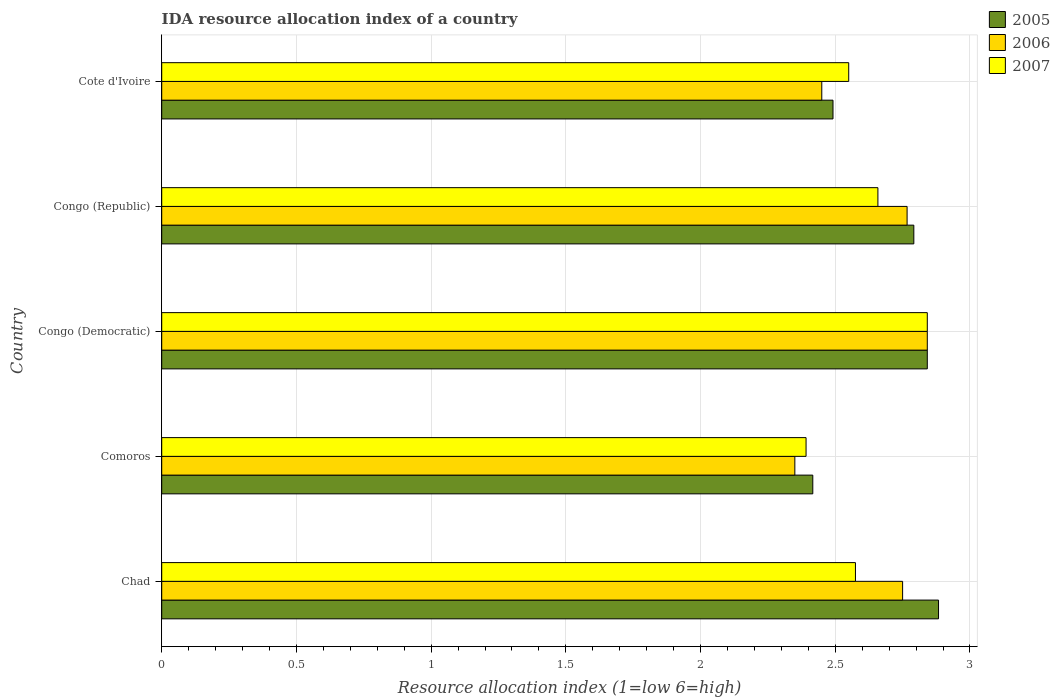How many different coloured bars are there?
Your answer should be very brief. 3. Are the number of bars on each tick of the Y-axis equal?
Your response must be concise. Yes. How many bars are there on the 1st tick from the bottom?
Ensure brevity in your answer.  3. What is the label of the 5th group of bars from the top?
Your response must be concise. Chad. In how many cases, is the number of bars for a given country not equal to the number of legend labels?
Keep it short and to the point. 0. What is the IDA resource allocation index in 2007 in Comoros?
Give a very brief answer. 2.39. Across all countries, what is the maximum IDA resource allocation index in 2007?
Make the answer very short. 2.84. Across all countries, what is the minimum IDA resource allocation index in 2006?
Keep it short and to the point. 2.35. In which country was the IDA resource allocation index in 2006 maximum?
Offer a very short reply. Congo (Democratic). In which country was the IDA resource allocation index in 2006 minimum?
Your answer should be very brief. Comoros. What is the total IDA resource allocation index in 2007 in the graph?
Keep it short and to the point. 13.02. What is the difference between the IDA resource allocation index in 2005 in Congo (Democratic) and that in Cote d'Ivoire?
Make the answer very short. 0.35. What is the difference between the IDA resource allocation index in 2007 in Comoros and the IDA resource allocation index in 2005 in Congo (Democratic)?
Ensure brevity in your answer.  -0.45. What is the average IDA resource allocation index in 2006 per country?
Give a very brief answer. 2.63. What is the ratio of the IDA resource allocation index in 2006 in Chad to that in Cote d'Ivoire?
Make the answer very short. 1.12. Is the IDA resource allocation index in 2007 in Chad less than that in Comoros?
Your response must be concise. No. Is the difference between the IDA resource allocation index in 2007 in Comoros and Cote d'Ivoire greater than the difference between the IDA resource allocation index in 2006 in Comoros and Cote d'Ivoire?
Give a very brief answer. No. What is the difference between the highest and the second highest IDA resource allocation index in 2007?
Ensure brevity in your answer.  0.18. What is the difference between the highest and the lowest IDA resource allocation index in 2006?
Keep it short and to the point. 0.49. Is the sum of the IDA resource allocation index in 2006 in Chad and Congo (Democratic) greater than the maximum IDA resource allocation index in 2007 across all countries?
Make the answer very short. Yes. What does the 3rd bar from the top in Chad represents?
Provide a short and direct response. 2005. What does the 2nd bar from the bottom in Chad represents?
Provide a short and direct response. 2006. How many bars are there?
Provide a succinct answer. 15. How many countries are there in the graph?
Provide a short and direct response. 5. What is the difference between two consecutive major ticks on the X-axis?
Offer a very short reply. 0.5. Are the values on the major ticks of X-axis written in scientific E-notation?
Provide a short and direct response. No. Does the graph contain any zero values?
Keep it short and to the point. No. Does the graph contain grids?
Offer a very short reply. Yes. How many legend labels are there?
Give a very brief answer. 3. What is the title of the graph?
Your answer should be compact. IDA resource allocation index of a country. Does "1964" appear as one of the legend labels in the graph?
Offer a very short reply. No. What is the label or title of the X-axis?
Provide a succinct answer. Resource allocation index (1=low 6=high). What is the label or title of the Y-axis?
Your response must be concise. Country. What is the Resource allocation index (1=low 6=high) of 2005 in Chad?
Offer a terse response. 2.88. What is the Resource allocation index (1=low 6=high) in 2006 in Chad?
Your answer should be very brief. 2.75. What is the Resource allocation index (1=low 6=high) of 2007 in Chad?
Provide a short and direct response. 2.58. What is the Resource allocation index (1=low 6=high) of 2005 in Comoros?
Your response must be concise. 2.42. What is the Resource allocation index (1=low 6=high) of 2006 in Comoros?
Give a very brief answer. 2.35. What is the Resource allocation index (1=low 6=high) of 2007 in Comoros?
Offer a very short reply. 2.39. What is the Resource allocation index (1=low 6=high) of 2005 in Congo (Democratic)?
Give a very brief answer. 2.84. What is the Resource allocation index (1=low 6=high) in 2006 in Congo (Democratic)?
Offer a terse response. 2.84. What is the Resource allocation index (1=low 6=high) in 2007 in Congo (Democratic)?
Give a very brief answer. 2.84. What is the Resource allocation index (1=low 6=high) in 2005 in Congo (Republic)?
Give a very brief answer. 2.79. What is the Resource allocation index (1=low 6=high) of 2006 in Congo (Republic)?
Your answer should be compact. 2.77. What is the Resource allocation index (1=low 6=high) of 2007 in Congo (Republic)?
Provide a succinct answer. 2.66. What is the Resource allocation index (1=low 6=high) in 2005 in Cote d'Ivoire?
Your answer should be very brief. 2.49. What is the Resource allocation index (1=low 6=high) of 2006 in Cote d'Ivoire?
Offer a very short reply. 2.45. What is the Resource allocation index (1=low 6=high) in 2007 in Cote d'Ivoire?
Your answer should be compact. 2.55. Across all countries, what is the maximum Resource allocation index (1=low 6=high) of 2005?
Ensure brevity in your answer.  2.88. Across all countries, what is the maximum Resource allocation index (1=low 6=high) in 2006?
Offer a very short reply. 2.84. Across all countries, what is the maximum Resource allocation index (1=low 6=high) of 2007?
Give a very brief answer. 2.84. Across all countries, what is the minimum Resource allocation index (1=low 6=high) in 2005?
Your answer should be very brief. 2.42. Across all countries, what is the minimum Resource allocation index (1=low 6=high) in 2006?
Provide a succinct answer. 2.35. Across all countries, what is the minimum Resource allocation index (1=low 6=high) of 2007?
Make the answer very short. 2.39. What is the total Resource allocation index (1=low 6=high) in 2005 in the graph?
Keep it short and to the point. 13.43. What is the total Resource allocation index (1=low 6=high) in 2006 in the graph?
Your answer should be very brief. 13.16. What is the total Resource allocation index (1=low 6=high) in 2007 in the graph?
Ensure brevity in your answer.  13.02. What is the difference between the Resource allocation index (1=low 6=high) in 2005 in Chad and that in Comoros?
Your answer should be very brief. 0.47. What is the difference between the Resource allocation index (1=low 6=high) of 2006 in Chad and that in Comoros?
Your answer should be very brief. 0.4. What is the difference between the Resource allocation index (1=low 6=high) of 2007 in Chad and that in Comoros?
Make the answer very short. 0.18. What is the difference between the Resource allocation index (1=low 6=high) of 2005 in Chad and that in Congo (Democratic)?
Provide a short and direct response. 0.04. What is the difference between the Resource allocation index (1=low 6=high) in 2006 in Chad and that in Congo (Democratic)?
Ensure brevity in your answer.  -0.09. What is the difference between the Resource allocation index (1=low 6=high) of 2007 in Chad and that in Congo (Democratic)?
Your answer should be compact. -0.27. What is the difference between the Resource allocation index (1=low 6=high) of 2005 in Chad and that in Congo (Republic)?
Make the answer very short. 0.09. What is the difference between the Resource allocation index (1=low 6=high) of 2006 in Chad and that in Congo (Republic)?
Your answer should be very brief. -0.02. What is the difference between the Resource allocation index (1=low 6=high) of 2007 in Chad and that in Congo (Republic)?
Provide a short and direct response. -0.08. What is the difference between the Resource allocation index (1=low 6=high) of 2005 in Chad and that in Cote d'Ivoire?
Ensure brevity in your answer.  0.39. What is the difference between the Resource allocation index (1=low 6=high) of 2006 in Chad and that in Cote d'Ivoire?
Ensure brevity in your answer.  0.3. What is the difference between the Resource allocation index (1=low 6=high) of 2007 in Chad and that in Cote d'Ivoire?
Your answer should be very brief. 0.03. What is the difference between the Resource allocation index (1=low 6=high) of 2005 in Comoros and that in Congo (Democratic)?
Provide a short and direct response. -0.42. What is the difference between the Resource allocation index (1=low 6=high) of 2006 in Comoros and that in Congo (Democratic)?
Ensure brevity in your answer.  -0.49. What is the difference between the Resource allocation index (1=low 6=high) of 2007 in Comoros and that in Congo (Democratic)?
Offer a very short reply. -0.45. What is the difference between the Resource allocation index (1=low 6=high) in 2005 in Comoros and that in Congo (Republic)?
Your answer should be compact. -0.38. What is the difference between the Resource allocation index (1=low 6=high) in 2006 in Comoros and that in Congo (Republic)?
Your answer should be compact. -0.42. What is the difference between the Resource allocation index (1=low 6=high) in 2007 in Comoros and that in Congo (Republic)?
Keep it short and to the point. -0.27. What is the difference between the Resource allocation index (1=low 6=high) of 2005 in Comoros and that in Cote d'Ivoire?
Provide a short and direct response. -0.07. What is the difference between the Resource allocation index (1=low 6=high) of 2007 in Comoros and that in Cote d'Ivoire?
Ensure brevity in your answer.  -0.16. What is the difference between the Resource allocation index (1=low 6=high) in 2006 in Congo (Democratic) and that in Congo (Republic)?
Make the answer very short. 0.07. What is the difference between the Resource allocation index (1=low 6=high) of 2007 in Congo (Democratic) and that in Congo (Republic)?
Your answer should be very brief. 0.18. What is the difference between the Resource allocation index (1=low 6=high) in 2006 in Congo (Democratic) and that in Cote d'Ivoire?
Your response must be concise. 0.39. What is the difference between the Resource allocation index (1=low 6=high) in 2007 in Congo (Democratic) and that in Cote d'Ivoire?
Ensure brevity in your answer.  0.29. What is the difference between the Resource allocation index (1=low 6=high) in 2005 in Congo (Republic) and that in Cote d'Ivoire?
Provide a succinct answer. 0.3. What is the difference between the Resource allocation index (1=low 6=high) of 2006 in Congo (Republic) and that in Cote d'Ivoire?
Provide a short and direct response. 0.32. What is the difference between the Resource allocation index (1=low 6=high) in 2007 in Congo (Republic) and that in Cote d'Ivoire?
Give a very brief answer. 0.11. What is the difference between the Resource allocation index (1=low 6=high) in 2005 in Chad and the Resource allocation index (1=low 6=high) in 2006 in Comoros?
Your response must be concise. 0.53. What is the difference between the Resource allocation index (1=low 6=high) in 2005 in Chad and the Resource allocation index (1=low 6=high) in 2007 in Comoros?
Make the answer very short. 0.49. What is the difference between the Resource allocation index (1=low 6=high) in 2006 in Chad and the Resource allocation index (1=low 6=high) in 2007 in Comoros?
Give a very brief answer. 0.36. What is the difference between the Resource allocation index (1=low 6=high) of 2005 in Chad and the Resource allocation index (1=low 6=high) of 2006 in Congo (Democratic)?
Ensure brevity in your answer.  0.04. What is the difference between the Resource allocation index (1=low 6=high) in 2005 in Chad and the Resource allocation index (1=low 6=high) in 2007 in Congo (Democratic)?
Ensure brevity in your answer.  0.04. What is the difference between the Resource allocation index (1=low 6=high) of 2006 in Chad and the Resource allocation index (1=low 6=high) of 2007 in Congo (Democratic)?
Offer a very short reply. -0.09. What is the difference between the Resource allocation index (1=low 6=high) of 2005 in Chad and the Resource allocation index (1=low 6=high) of 2006 in Congo (Republic)?
Ensure brevity in your answer.  0.12. What is the difference between the Resource allocation index (1=low 6=high) in 2005 in Chad and the Resource allocation index (1=low 6=high) in 2007 in Congo (Republic)?
Keep it short and to the point. 0.23. What is the difference between the Resource allocation index (1=low 6=high) in 2006 in Chad and the Resource allocation index (1=low 6=high) in 2007 in Congo (Republic)?
Offer a very short reply. 0.09. What is the difference between the Resource allocation index (1=low 6=high) of 2005 in Chad and the Resource allocation index (1=low 6=high) of 2006 in Cote d'Ivoire?
Ensure brevity in your answer.  0.43. What is the difference between the Resource allocation index (1=low 6=high) of 2005 in Chad and the Resource allocation index (1=low 6=high) of 2007 in Cote d'Ivoire?
Offer a terse response. 0.33. What is the difference between the Resource allocation index (1=low 6=high) of 2005 in Comoros and the Resource allocation index (1=low 6=high) of 2006 in Congo (Democratic)?
Give a very brief answer. -0.42. What is the difference between the Resource allocation index (1=low 6=high) of 2005 in Comoros and the Resource allocation index (1=low 6=high) of 2007 in Congo (Democratic)?
Make the answer very short. -0.42. What is the difference between the Resource allocation index (1=low 6=high) in 2006 in Comoros and the Resource allocation index (1=low 6=high) in 2007 in Congo (Democratic)?
Your answer should be very brief. -0.49. What is the difference between the Resource allocation index (1=low 6=high) in 2005 in Comoros and the Resource allocation index (1=low 6=high) in 2006 in Congo (Republic)?
Make the answer very short. -0.35. What is the difference between the Resource allocation index (1=low 6=high) in 2005 in Comoros and the Resource allocation index (1=low 6=high) in 2007 in Congo (Republic)?
Make the answer very short. -0.24. What is the difference between the Resource allocation index (1=low 6=high) in 2006 in Comoros and the Resource allocation index (1=low 6=high) in 2007 in Congo (Republic)?
Make the answer very short. -0.31. What is the difference between the Resource allocation index (1=low 6=high) of 2005 in Comoros and the Resource allocation index (1=low 6=high) of 2006 in Cote d'Ivoire?
Give a very brief answer. -0.03. What is the difference between the Resource allocation index (1=low 6=high) of 2005 in Comoros and the Resource allocation index (1=low 6=high) of 2007 in Cote d'Ivoire?
Ensure brevity in your answer.  -0.13. What is the difference between the Resource allocation index (1=low 6=high) in 2005 in Congo (Democratic) and the Resource allocation index (1=low 6=high) in 2006 in Congo (Republic)?
Keep it short and to the point. 0.07. What is the difference between the Resource allocation index (1=low 6=high) in 2005 in Congo (Democratic) and the Resource allocation index (1=low 6=high) in 2007 in Congo (Republic)?
Make the answer very short. 0.18. What is the difference between the Resource allocation index (1=low 6=high) in 2006 in Congo (Democratic) and the Resource allocation index (1=low 6=high) in 2007 in Congo (Republic)?
Make the answer very short. 0.18. What is the difference between the Resource allocation index (1=low 6=high) of 2005 in Congo (Democratic) and the Resource allocation index (1=low 6=high) of 2006 in Cote d'Ivoire?
Ensure brevity in your answer.  0.39. What is the difference between the Resource allocation index (1=low 6=high) in 2005 in Congo (Democratic) and the Resource allocation index (1=low 6=high) in 2007 in Cote d'Ivoire?
Your answer should be very brief. 0.29. What is the difference between the Resource allocation index (1=low 6=high) in 2006 in Congo (Democratic) and the Resource allocation index (1=low 6=high) in 2007 in Cote d'Ivoire?
Offer a terse response. 0.29. What is the difference between the Resource allocation index (1=low 6=high) of 2005 in Congo (Republic) and the Resource allocation index (1=low 6=high) of 2006 in Cote d'Ivoire?
Your answer should be very brief. 0.34. What is the difference between the Resource allocation index (1=low 6=high) in 2005 in Congo (Republic) and the Resource allocation index (1=low 6=high) in 2007 in Cote d'Ivoire?
Offer a terse response. 0.24. What is the difference between the Resource allocation index (1=low 6=high) of 2006 in Congo (Republic) and the Resource allocation index (1=low 6=high) of 2007 in Cote d'Ivoire?
Provide a succinct answer. 0.22. What is the average Resource allocation index (1=low 6=high) in 2005 per country?
Make the answer very short. 2.69. What is the average Resource allocation index (1=low 6=high) of 2006 per country?
Your response must be concise. 2.63. What is the average Resource allocation index (1=low 6=high) of 2007 per country?
Your response must be concise. 2.6. What is the difference between the Resource allocation index (1=low 6=high) of 2005 and Resource allocation index (1=low 6=high) of 2006 in Chad?
Offer a very short reply. 0.13. What is the difference between the Resource allocation index (1=low 6=high) of 2005 and Resource allocation index (1=low 6=high) of 2007 in Chad?
Provide a short and direct response. 0.31. What is the difference between the Resource allocation index (1=low 6=high) of 2006 and Resource allocation index (1=low 6=high) of 2007 in Chad?
Your response must be concise. 0.17. What is the difference between the Resource allocation index (1=low 6=high) of 2005 and Resource allocation index (1=low 6=high) of 2006 in Comoros?
Provide a succinct answer. 0.07. What is the difference between the Resource allocation index (1=low 6=high) in 2005 and Resource allocation index (1=low 6=high) in 2007 in Comoros?
Your answer should be very brief. 0.03. What is the difference between the Resource allocation index (1=low 6=high) in 2006 and Resource allocation index (1=low 6=high) in 2007 in Comoros?
Keep it short and to the point. -0.04. What is the difference between the Resource allocation index (1=low 6=high) in 2005 and Resource allocation index (1=low 6=high) in 2007 in Congo (Democratic)?
Your response must be concise. 0. What is the difference between the Resource allocation index (1=low 6=high) of 2006 and Resource allocation index (1=low 6=high) of 2007 in Congo (Democratic)?
Keep it short and to the point. 0. What is the difference between the Resource allocation index (1=low 6=high) in 2005 and Resource allocation index (1=low 6=high) in 2006 in Congo (Republic)?
Offer a very short reply. 0.03. What is the difference between the Resource allocation index (1=low 6=high) of 2005 and Resource allocation index (1=low 6=high) of 2007 in Congo (Republic)?
Provide a short and direct response. 0.13. What is the difference between the Resource allocation index (1=low 6=high) in 2006 and Resource allocation index (1=low 6=high) in 2007 in Congo (Republic)?
Provide a succinct answer. 0.11. What is the difference between the Resource allocation index (1=low 6=high) in 2005 and Resource allocation index (1=low 6=high) in 2006 in Cote d'Ivoire?
Provide a short and direct response. 0.04. What is the difference between the Resource allocation index (1=low 6=high) in 2005 and Resource allocation index (1=low 6=high) in 2007 in Cote d'Ivoire?
Keep it short and to the point. -0.06. What is the ratio of the Resource allocation index (1=low 6=high) in 2005 in Chad to that in Comoros?
Keep it short and to the point. 1.19. What is the ratio of the Resource allocation index (1=low 6=high) of 2006 in Chad to that in Comoros?
Keep it short and to the point. 1.17. What is the ratio of the Resource allocation index (1=low 6=high) in 2007 in Chad to that in Comoros?
Make the answer very short. 1.08. What is the ratio of the Resource allocation index (1=low 6=high) of 2005 in Chad to that in Congo (Democratic)?
Make the answer very short. 1.01. What is the ratio of the Resource allocation index (1=low 6=high) of 2006 in Chad to that in Congo (Democratic)?
Give a very brief answer. 0.97. What is the ratio of the Resource allocation index (1=low 6=high) in 2007 in Chad to that in Congo (Democratic)?
Your answer should be very brief. 0.91. What is the ratio of the Resource allocation index (1=low 6=high) of 2005 in Chad to that in Congo (Republic)?
Offer a terse response. 1.03. What is the ratio of the Resource allocation index (1=low 6=high) in 2006 in Chad to that in Congo (Republic)?
Your response must be concise. 0.99. What is the ratio of the Resource allocation index (1=low 6=high) in 2007 in Chad to that in Congo (Republic)?
Your answer should be compact. 0.97. What is the ratio of the Resource allocation index (1=low 6=high) of 2005 in Chad to that in Cote d'Ivoire?
Provide a short and direct response. 1.16. What is the ratio of the Resource allocation index (1=low 6=high) of 2006 in Chad to that in Cote d'Ivoire?
Your answer should be very brief. 1.12. What is the ratio of the Resource allocation index (1=low 6=high) in 2007 in Chad to that in Cote d'Ivoire?
Your answer should be compact. 1.01. What is the ratio of the Resource allocation index (1=low 6=high) of 2005 in Comoros to that in Congo (Democratic)?
Your answer should be compact. 0.85. What is the ratio of the Resource allocation index (1=low 6=high) of 2006 in Comoros to that in Congo (Democratic)?
Give a very brief answer. 0.83. What is the ratio of the Resource allocation index (1=low 6=high) of 2007 in Comoros to that in Congo (Democratic)?
Ensure brevity in your answer.  0.84. What is the ratio of the Resource allocation index (1=low 6=high) in 2005 in Comoros to that in Congo (Republic)?
Ensure brevity in your answer.  0.87. What is the ratio of the Resource allocation index (1=low 6=high) in 2006 in Comoros to that in Congo (Republic)?
Your answer should be very brief. 0.85. What is the ratio of the Resource allocation index (1=low 6=high) in 2007 in Comoros to that in Congo (Republic)?
Provide a short and direct response. 0.9. What is the ratio of the Resource allocation index (1=low 6=high) in 2005 in Comoros to that in Cote d'Ivoire?
Provide a short and direct response. 0.97. What is the ratio of the Resource allocation index (1=low 6=high) of 2006 in Comoros to that in Cote d'Ivoire?
Offer a terse response. 0.96. What is the ratio of the Resource allocation index (1=low 6=high) of 2007 in Comoros to that in Cote d'Ivoire?
Your answer should be very brief. 0.94. What is the ratio of the Resource allocation index (1=low 6=high) of 2005 in Congo (Democratic) to that in Congo (Republic)?
Keep it short and to the point. 1.02. What is the ratio of the Resource allocation index (1=low 6=high) in 2006 in Congo (Democratic) to that in Congo (Republic)?
Provide a succinct answer. 1.03. What is the ratio of the Resource allocation index (1=low 6=high) in 2007 in Congo (Democratic) to that in Congo (Republic)?
Make the answer very short. 1.07. What is the ratio of the Resource allocation index (1=low 6=high) of 2005 in Congo (Democratic) to that in Cote d'Ivoire?
Keep it short and to the point. 1.14. What is the ratio of the Resource allocation index (1=low 6=high) of 2006 in Congo (Democratic) to that in Cote d'Ivoire?
Provide a succinct answer. 1.16. What is the ratio of the Resource allocation index (1=low 6=high) in 2007 in Congo (Democratic) to that in Cote d'Ivoire?
Keep it short and to the point. 1.11. What is the ratio of the Resource allocation index (1=low 6=high) in 2005 in Congo (Republic) to that in Cote d'Ivoire?
Your response must be concise. 1.12. What is the ratio of the Resource allocation index (1=low 6=high) of 2006 in Congo (Republic) to that in Cote d'Ivoire?
Keep it short and to the point. 1.13. What is the ratio of the Resource allocation index (1=low 6=high) of 2007 in Congo (Republic) to that in Cote d'Ivoire?
Your answer should be very brief. 1.04. What is the difference between the highest and the second highest Resource allocation index (1=low 6=high) in 2005?
Keep it short and to the point. 0.04. What is the difference between the highest and the second highest Resource allocation index (1=low 6=high) of 2006?
Provide a succinct answer. 0.07. What is the difference between the highest and the second highest Resource allocation index (1=low 6=high) of 2007?
Offer a very short reply. 0.18. What is the difference between the highest and the lowest Resource allocation index (1=low 6=high) of 2005?
Your response must be concise. 0.47. What is the difference between the highest and the lowest Resource allocation index (1=low 6=high) in 2006?
Your answer should be very brief. 0.49. What is the difference between the highest and the lowest Resource allocation index (1=low 6=high) of 2007?
Make the answer very short. 0.45. 